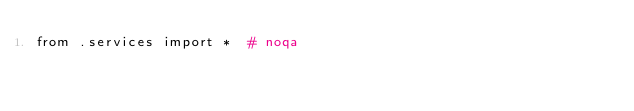Convert code to text. <code><loc_0><loc_0><loc_500><loc_500><_Python_>from .services import *  # noqa
</code> 